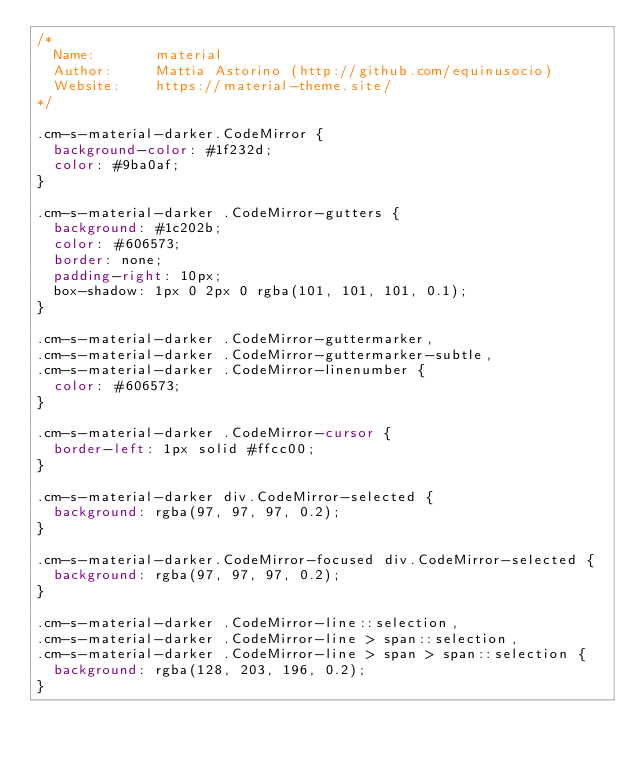Convert code to text. <code><loc_0><loc_0><loc_500><loc_500><_CSS_>/*
  Name:       material
  Author:     Mattia Astorino (http://github.com/equinusocio)
  Website:    https://material-theme.site/
*/

.cm-s-material-darker.CodeMirror {
  background-color: #1f232d;
  color: #9ba0af;
}

.cm-s-material-darker .CodeMirror-gutters {
  background: #1c202b;
  color: #606573;
  border: none;
  padding-right: 10px;
  box-shadow: 1px 0 2px 0 rgba(101, 101, 101, 0.1);
}

.cm-s-material-darker .CodeMirror-guttermarker,
.cm-s-material-darker .CodeMirror-guttermarker-subtle,
.cm-s-material-darker .CodeMirror-linenumber {
  color: #606573;
}

.cm-s-material-darker .CodeMirror-cursor {
  border-left: 1px solid #ffcc00;
}

.cm-s-material-darker div.CodeMirror-selected {
  background: rgba(97, 97, 97, 0.2);
}

.cm-s-material-darker.CodeMirror-focused div.CodeMirror-selected {
  background: rgba(97, 97, 97, 0.2);
}

.cm-s-material-darker .CodeMirror-line::selection,
.cm-s-material-darker .CodeMirror-line > span::selection,
.cm-s-material-darker .CodeMirror-line > span > span::selection {
  background: rgba(128, 203, 196, 0.2);
}
</code> 